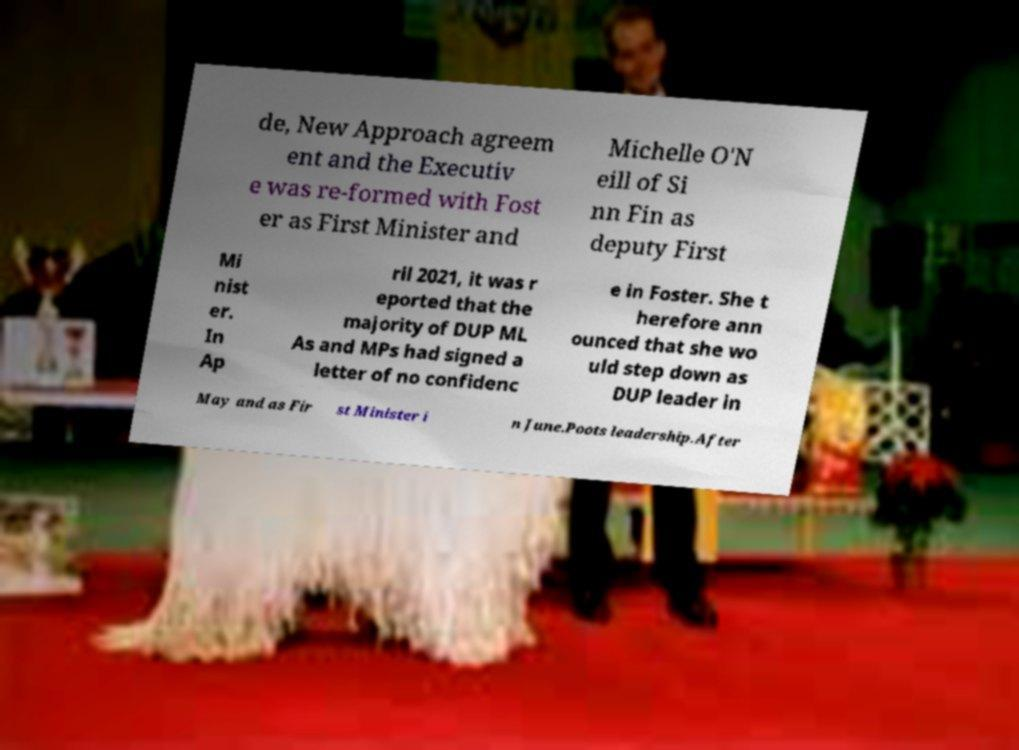Please identify and transcribe the text found in this image. de, New Approach agreem ent and the Executiv e was re-formed with Fost er as First Minister and Michelle O'N eill of Si nn Fin as deputy First Mi nist er. In Ap ril 2021, it was r eported that the majority of DUP ML As and MPs had signed a letter of no confidenc e in Foster. She t herefore ann ounced that she wo uld step down as DUP leader in May and as Fir st Minister i n June.Poots leadership.After 